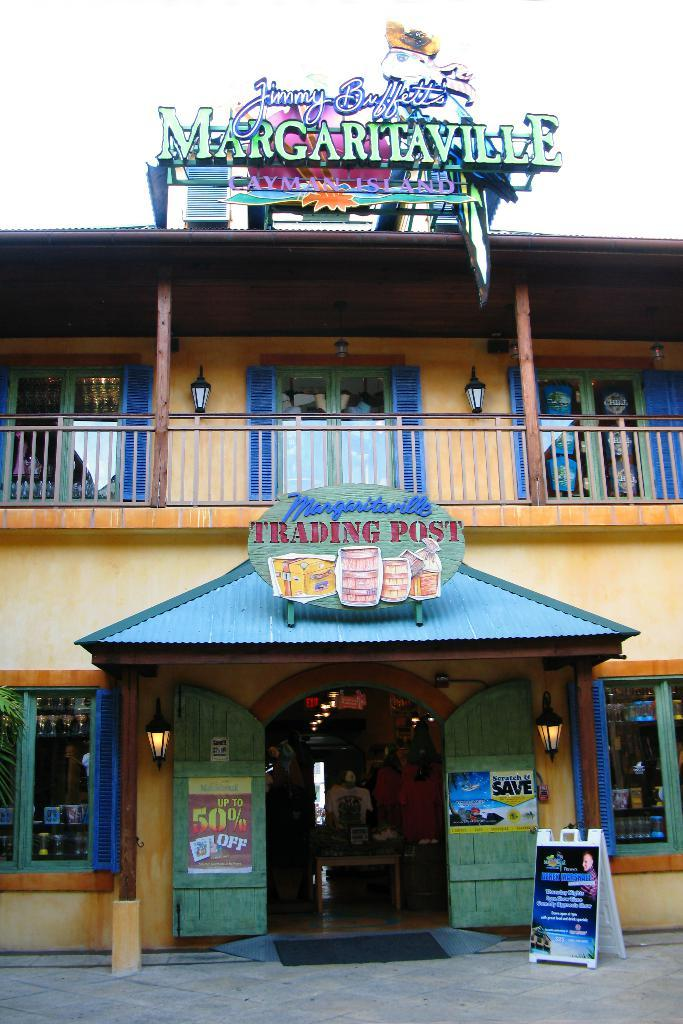<image>
Give a short and clear explanation of the subsequent image. Jimmy Buffet's Margaritaville Trading Post is currently open. 